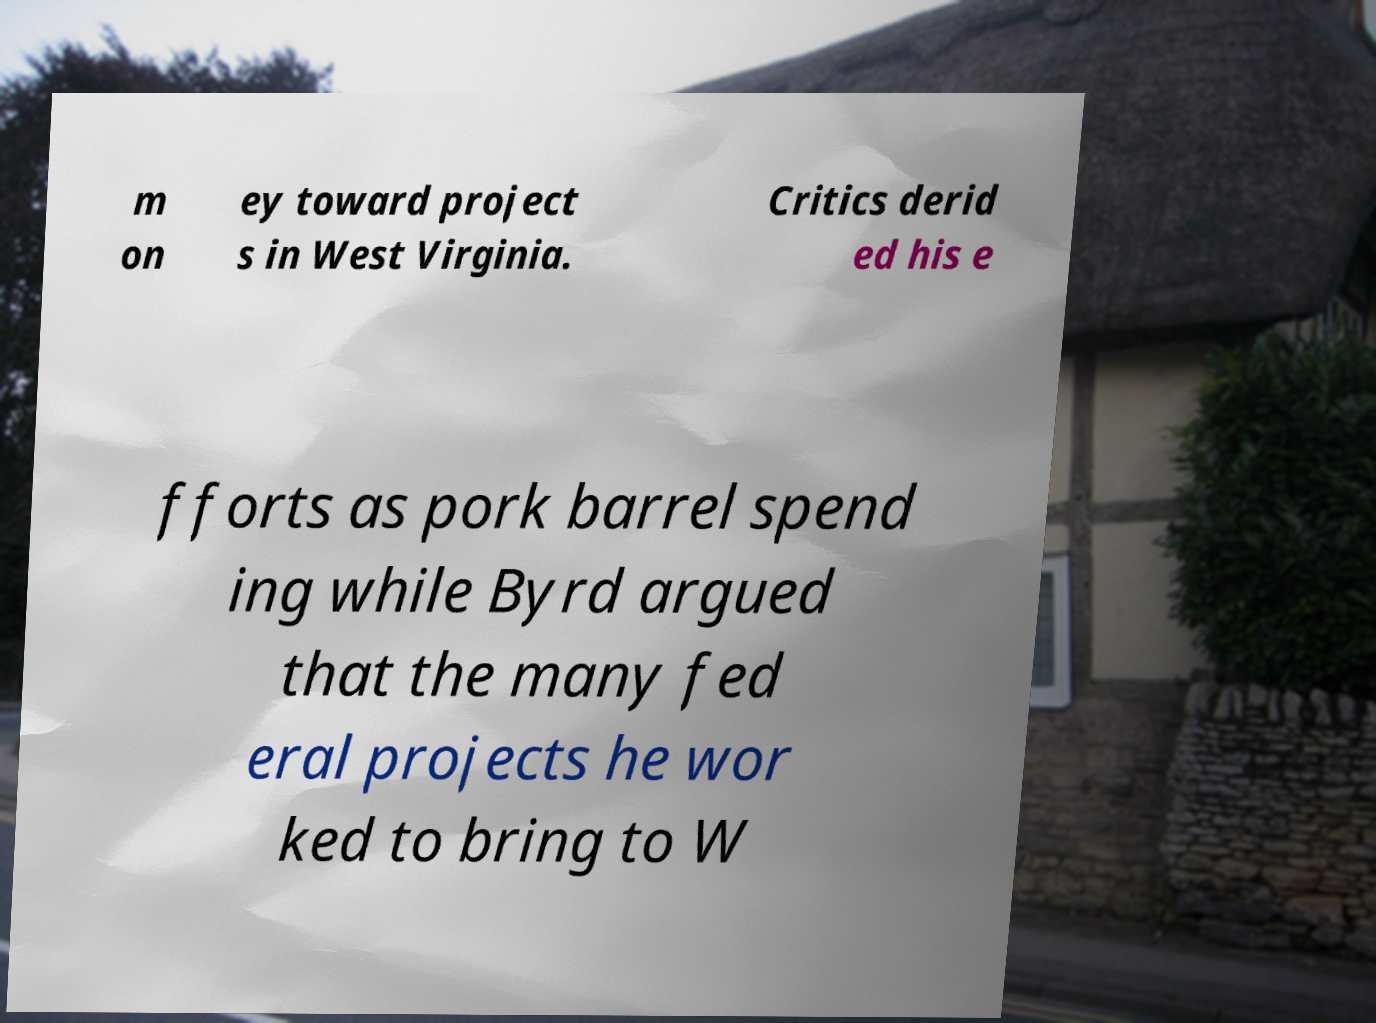Could you assist in decoding the text presented in this image and type it out clearly? m on ey toward project s in West Virginia. Critics derid ed his e fforts as pork barrel spend ing while Byrd argued that the many fed eral projects he wor ked to bring to W 